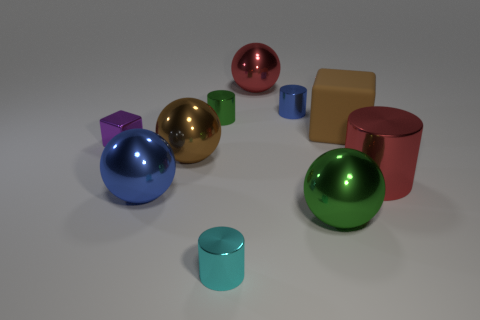Subtract 1 cylinders. How many cylinders are left? 3 Subtract all purple cylinders. Subtract all blue balls. How many cylinders are left? 4 Subtract all balls. How many objects are left? 6 Subtract 1 green cylinders. How many objects are left? 9 Subtract all cubes. Subtract all big green balls. How many objects are left? 7 Add 8 green shiny cylinders. How many green shiny cylinders are left? 9 Add 10 gray rubber balls. How many gray rubber balls exist? 10 